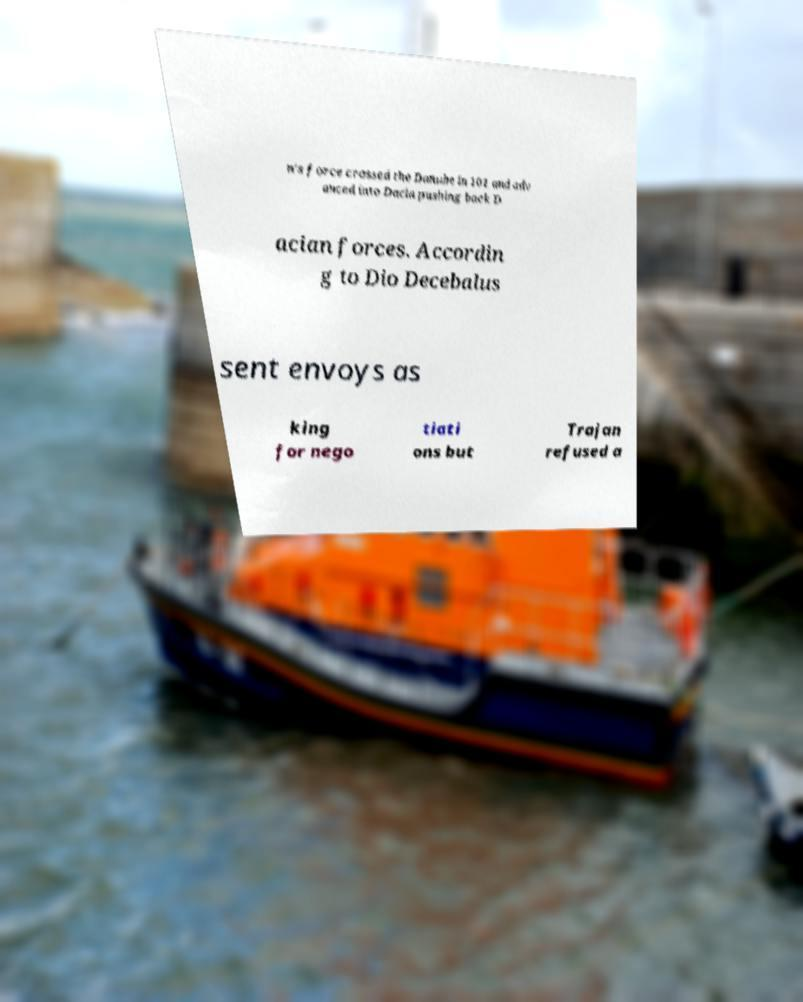Please identify and transcribe the text found in this image. n's force crossed the Danube in 101 and adv anced into Dacia pushing back D acian forces. Accordin g to Dio Decebalus sent envoys as king for nego tiati ons but Trajan refused a 